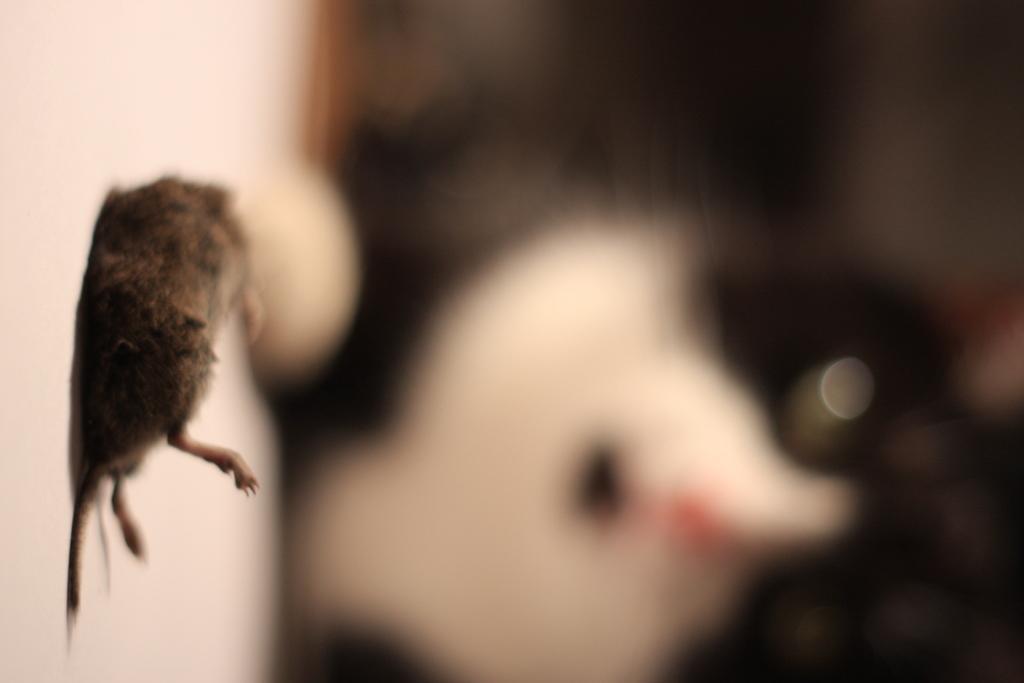In one or two sentences, can you explain what this image depicts? In this image there is an animal on the floor. Background is blurry. 